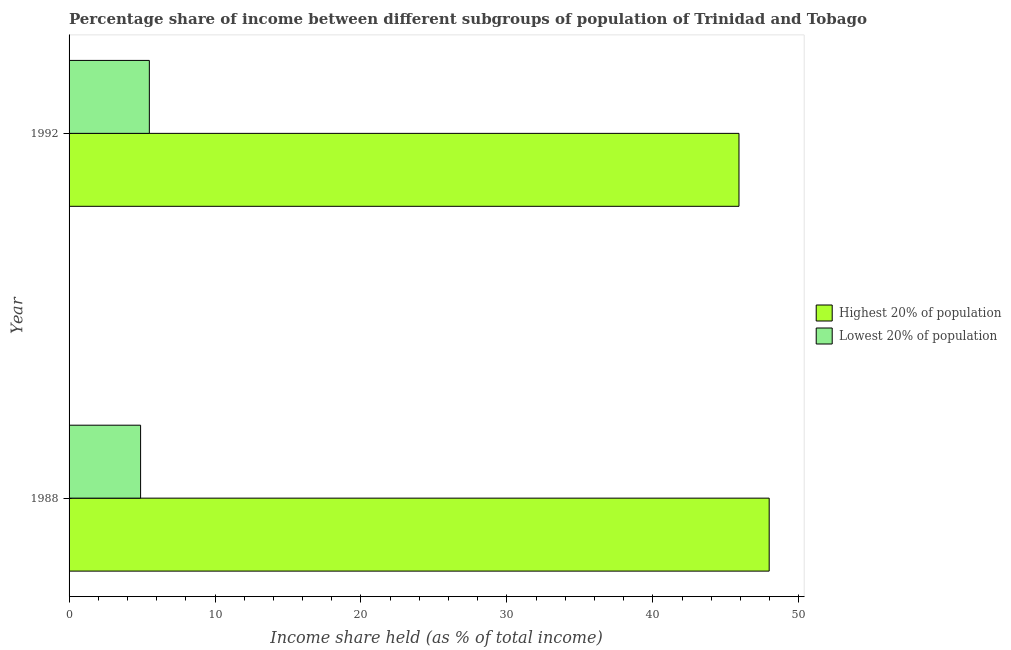Are the number of bars per tick equal to the number of legend labels?
Provide a succinct answer. Yes. What is the label of the 1st group of bars from the top?
Your response must be concise. 1992. In how many cases, is the number of bars for a given year not equal to the number of legend labels?
Give a very brief answer. 0. Across all years, what is the maximum income share held by lowest 20% of the population?
Your answer should be very brief. 5.5. Across all years, what is the minimum income share held by highest 20% of the population?
Provide a short and direct response. 45.9. In which year was the income share held by highest 20% of the population maximum?
Your response must be concise. 1988. In which year was the income share held by lowest 20% of the population minimum?
Your response must be concise. 1988. What is the total income share held by lowest 20% of the population in the graph?
Ensure brevity in your answer.  10.4. What is the difference between the income share held by highest 20% of the population in 1988 and that in 1992?
Your answer should be very brief. 2.07. What is the difference between the income share held by lowest 20% of the population in 1988 and the income share held by highest 20% of the population in 1992?
Provide a succinct answer. -41. What is the average income share held by highest 20% of the population per year?
Offer a very short reply. 46.94. In the year 1992, what is the difference between the income share held by lowest 20% of the population and income share held by highest 20% of the population?
Provide a short and direct response. -40.4. What is the ratio of the income share held by highest 20% of the population in 1988 to that in 1992?
Offer a very short reply. 1.04. Is the difference between the income share held by lowest 20% of the population in 1988 and 1992 greater than the difference between the income share held by highest 20% of the population in 1988 and 1992?
Offer a terse response. No. In how many years, is the income share held by lowest 20% of the population greater than the average income share held by lowest 20% of the population taken over all years?
Give a very brief answer. 1. What does the 2nd bar from the top in 1988 represents?
Make the answer very short. Highest 20% of population. What does the 1st bar from the bottom in 1988 represents?
Give a very brief answer. Highest 20% of population. Are all the bars in the graph horizontal?
Your answer should be very brief. Yes. How many years are there in the graph?
Ensure brevity in your answer.  2. What is the difference between two consecutive major ticks on the X-axis?
Offer a very short reply. 10. Does the graph contain any zero values?
Provide a succinct answer. No. Does the graph contain grids?
Provide a short and direct response. No. How are the legend labels stacked?
Offer a terse response. Vertical. What is the title of the graph?
Make the answer very short. Percentage share of income between different subgroups of population of Trinidad and Tobago. What is the label or title of the X-axis?
Your answer should be compact. Income share held (as % of total income). What is the label or title of the Y-axis?
Ensure brevity in your answer.  Year. What is the Income share held (as % of total income) in Highest 20% of population in 1988?
Ensure brevity in your answer.  47.97. What is the Income share held (as % of total income) in Lowest 20% of population in 1988?
Offer a terse response. 4.9. What is the Income share held (as % of total income) of Highest 20% of population in 1992?
Keep it short and to the point. 45.9. Across all years, what is the maximum Income share held (as % of total income) of Highest 20% of population?
Ensure brevity in your answer.  47.97. Across all years, what is the minimum Income share held (as % of total income) in Highest 20% of population?
Your response must be concise. 45.9. What is the total Income share held (as % of total income) in Highest 20% of population in the graph?
Provide a short and direct response. 93.87. What is the total Income share held (as % of total income) in Lowest 20% of population in the graph?
Your answer should be very brief. 10.4. What is the difference between the Income share held (as % of total income) of Highest 20% of population in 1988 and that in 1992?
Offer a very short reply. 2.07. What is the difference between the Income share held (as % of total income) in Highest 20% of population in 1988 and the Income share held (as % of total income) in Lowest 20% of population in 1992?
Ensure brevity in your answer.  42.47. What is the average Income share held (as % of total income) of Highest 20% of population per year?
Keep it short and to the point. 46.94. What is the average Income share held (as % of total income) in Lowest 20% of population per year?
Make the answer very short. 5.2. In the year 1988, what is the difference between the Income share held (as % of total income) in Highest 20% of population and Income share held (as % of total income) in Lowest 20% of population?
Your answer should be compact. 43.07. In the year 1992, what is the difference between the Income share held (as % of total income) of Highest 20% of population and Income share held (as % of total income) of Lowest 20% of population?
Your answer should be very brief. 40.4. What is the ratio of the Income share held (as % of total income) in Highest 20% of population in 1988 to that in 1992?
Give a very brief answer. 1.05. What is the ratio of the Income share held (as % of total income) in Lowest 20% of population in 1988 to that in 1992?
Keep it short and to the point. 0.89. What is the difference between the highest and the second highest Income share held (as % of total income) of Highest 20% of population?
Keep it short and to the point. 2.07. What is the difference between the highest and the second highest Income share held (as % of total income) in Lowest 20% of population?
Your response must be concise. 0.6. What is the difference between the highest and the lowest Income share held (as % of total income) of Highest 20% of population?
Offer a terse response. 2.07. What is the difference between the highest and the lowest Income share held (as % of total income) in Lowest 20% of population?
Make the answer very short. 0.6. 